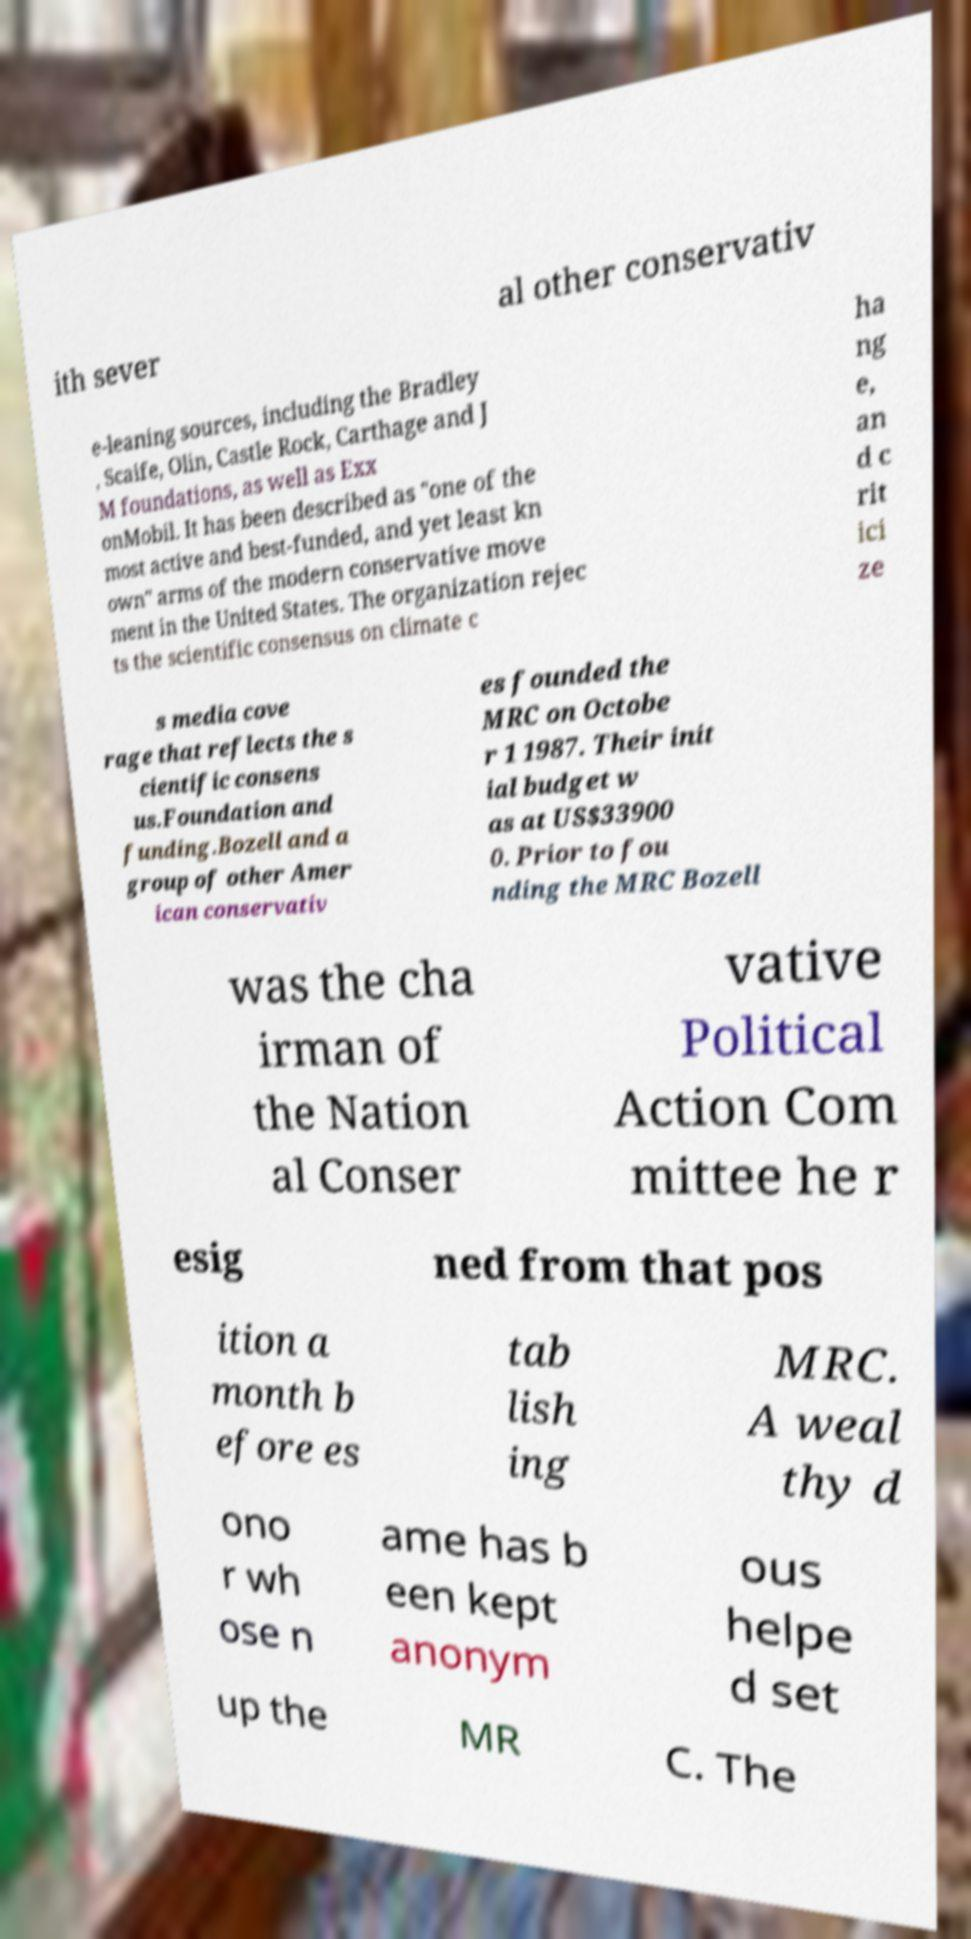Can you read and provide the text displayed in the image?This photo seems to have some interesting text. Can you extract and type it out for me? ith sever al other conservativ e-leaning sources, including the Bradley , Scaife, Olin, Castle Rock, Carthage and J M foundations, as well as Exx onMobil. It has been described as "one of the most active and best-funded, and yet least kn own" arms of the modern conservative move ment in the United States. The organization rejec ts the scientific consensus on climate c ha ng e, an d c rit ici ze s media cove rage that reflects the s cientific consens us.Foundation and funding.Bozell and a group of other Amer ican conservativ es founded the MRC on Octobe r 1 1987. Their init ial budget w as at US$33900 0. Prior to fou nding the MRC Bozell was the cha irman of the Nation al Conser vative Political Action Com mittee he r esig ned from that pos ition a month b efore es tab lish ing MRC. A weal thy d ono r wh ose n ame has b een kept anonym ous helpe d set up the MR C. The 